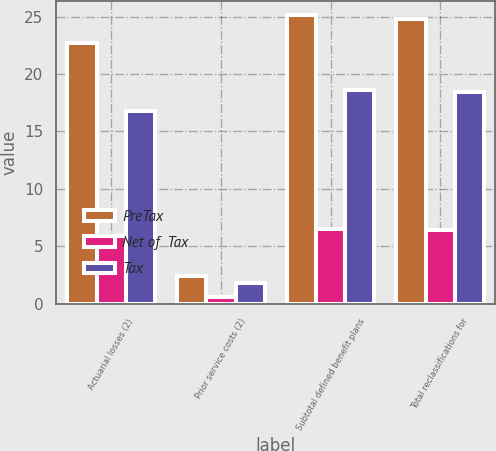Convert chart. <chart><loc_0><loc_0><loc_500><loc_500><stacked_bar_chart><ecel><fcel>Actuarial losses (2)<fcel>Prior service costs (2)<fcel>Subtotal defined benefit plans<fcel>Total reclassifications for<nl><fcel>PreTax<fcel>22.7<fcel>2.4<fcel>25.1<fcel>24.8<nl><fcel>Net of  Tax<fcel>5.9<fcel>0.6<fcel>6.5<fcel>6.4<nl><fcel>Tax<fcel>16.8<fcel>1.8<fcel>18.6<fcel>18.4<nl></chart> 